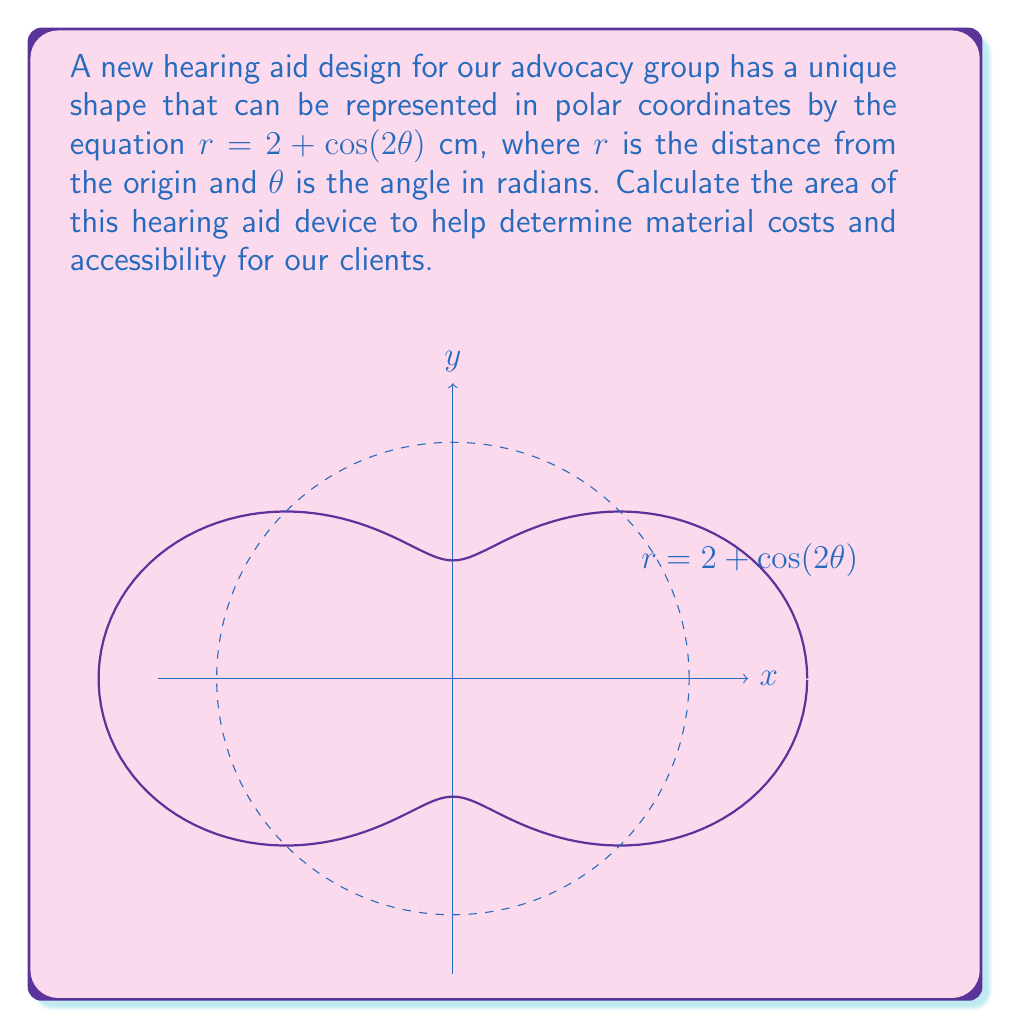Give your solution to this math problem. To calculate the area enclosed by a polar curve, we use the formula:

$$A = \frac{1}{2} \int_{0}^{2\pi} r^2(\theta) d\theta$$

For our hearing aid shape, $r(\theta) = 2 + \cos(2\theta)$. Let's follow these steps:

1) Square the radius function:
   $r^2(\theta) = (2 + \cos(2\theta))^2 = 4 + 4\cos(2\theta) + \cos^2(2\theta)$

2) Substitute this into our integral:
   $$A = \frac{1}{2} \int_{0}^{2\pi} (4 + 4\cos(2\theta) + \cos^2(2\theta)) d\theta$$

3) Integrate each term:
   - $\int_{0}^{2\pi} 4 d\theta = 4\theta |_{0}^{2\pi} = 8\pi$
   - $\int_{0}^{2\pi} 4\cos(2\theta) d\theta = 2\sin(2\theta) |_{0}^{2\pi} = 0$
   - $\int_{0}^{2\pi} \cos^2(2\theta) d\theta = \frac{1}{2}\int_{0}^{2\pi} (1 + \cos(4\theta)) d\theta = \frac{1}{2}(\theta + \frac{1}{4}\sin(4\theta)) |_{0}^{2\pi} = \pi$

4) Sum up the results:
   $$A = \frac{1}{2} (8\pi + 0 + \pi) = \frac{9\pi}{2}$$

Therefore, the area of the hearing aid device is $\frac{9\pi}{2}$ square centimeters.
Answer: $\frac{9\pi}{2}$ cm² 